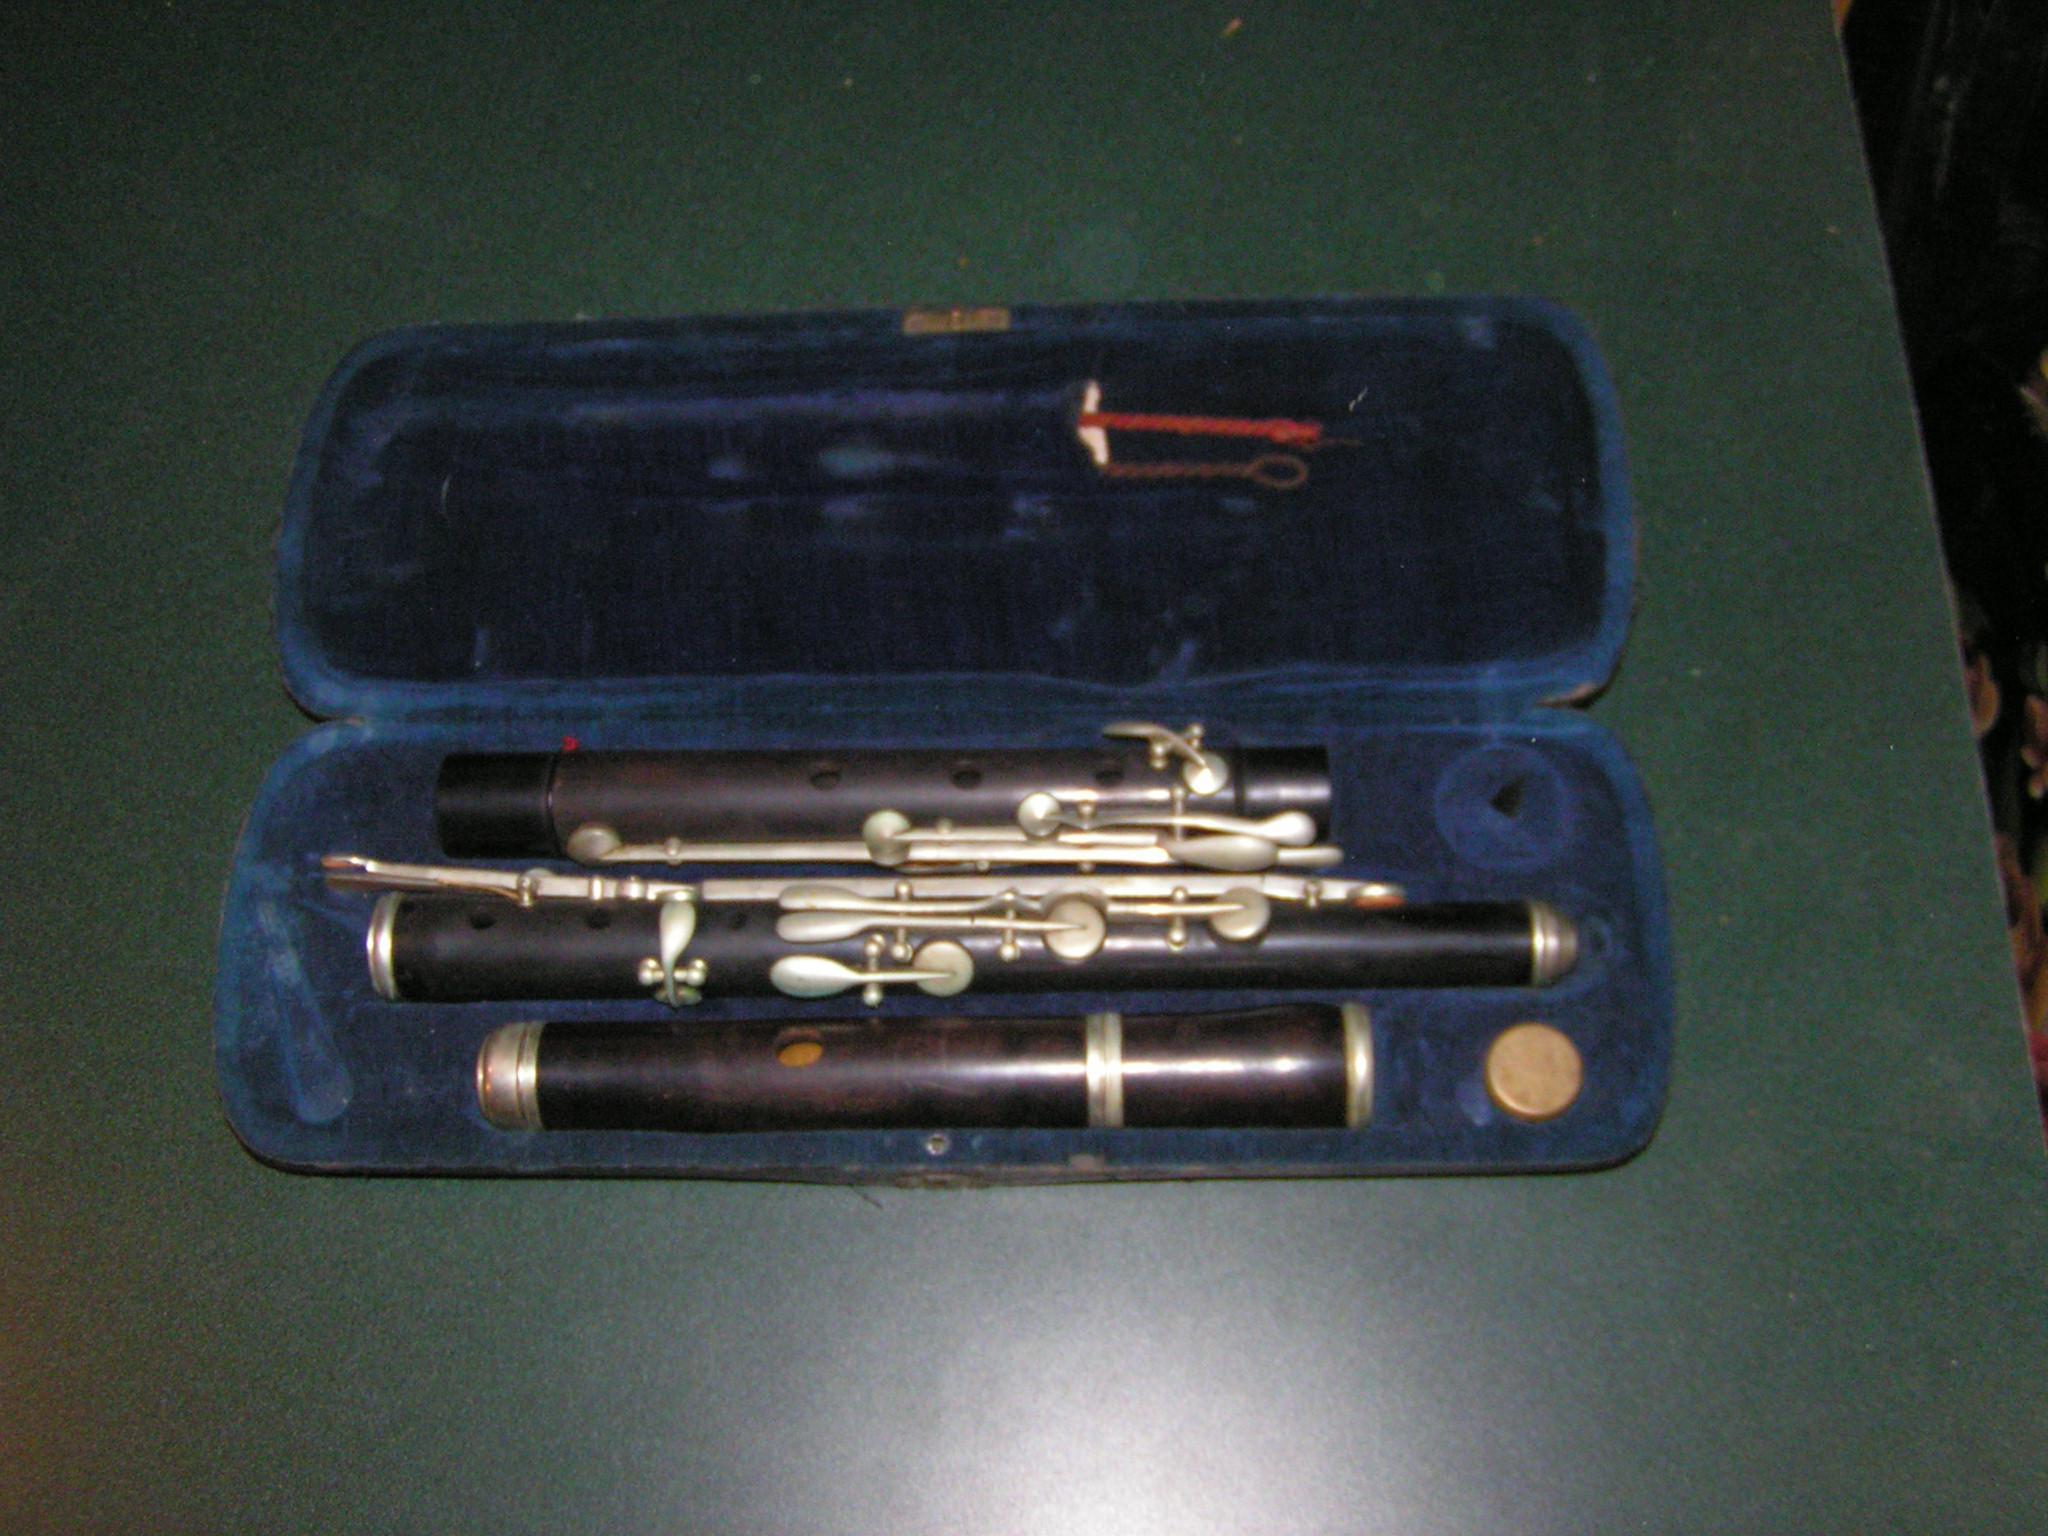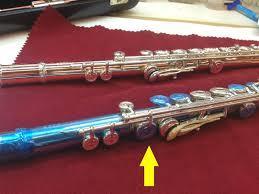The first image is the image on the left, the second image is the image on the right. Assess this claim about the two images: "One of the flutes is blue.". Correct or not? Answer yes or no. Yes. The first image is the image on the left, the second image is the image on the right. Analyze the images presented: Is the assertion "One image shows a disassembled instrument in an open case displayed horizontally, and the other image shows items that are not in a case." valid? Answer yes or no. Yes. 